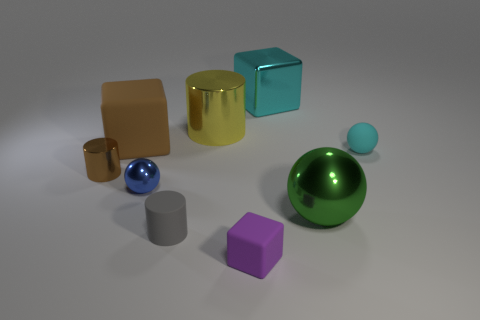How big is the cylinder behind the cube on the left side of the tiny sphere that is left of the cyan shiny thing?
Offer a very short reply. Large. How many other cylinders have the same color as the big cylinder?
Your answer should be compact. 0. What number of objects are either large matte things or matte things left of the large green metallic ball?
Your answer should be very brief. 3. The big rubber cube has what color?
Make the answer very short. Brown. The tiny rubber thing to the right of the green metallic ball is what color?
Provide a short and direct response. Cyan. How many rubber things are on the left side of the tiny ball on the right side of the purple object?
Your response must be concise. 3. There is a cyan cube; is it the same size as the metal ball on the right side of the purple object?
Offer a very short reply. Yes. Is there a metal block of the same size as the gray matte cylinder?
Keep it short and to the point. No. What number of things are either tiny purple rubber cubes or brown objects?
Offer a terse response. 3. There is a rubber thing that is in front of the rubber cylinder; does it have the same size as the brown thing behind the brown metal cylinder?
Your answer should be very brief. No. 